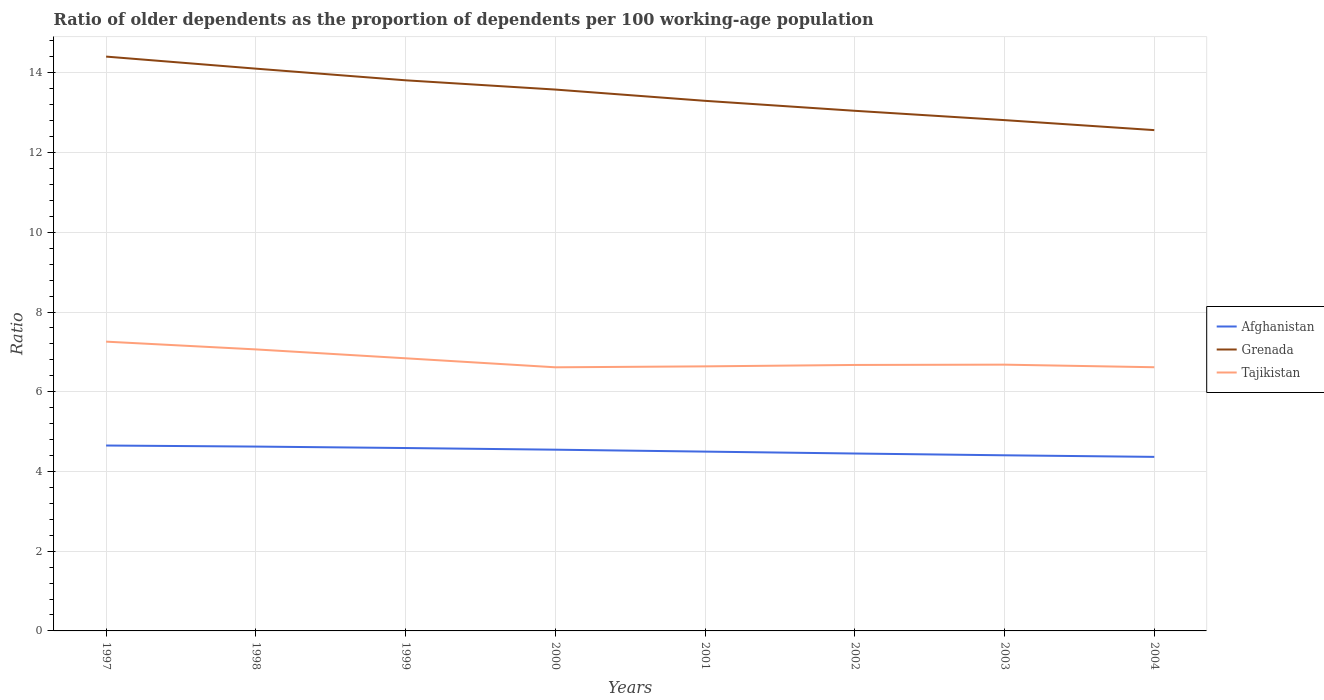How many different coloured lines are there?
Give a very brief answer. 3. Does the line corresponding to Afghanistan intersect with the line corresponding to Tajikistan?
Make the answer very short. No. Is the number of lines equal to the number of legend labels?
Give a very brief answer. Yes. Across all years, what is the maximum age dependency ratio(old) in Tajikistan?
Your response must be concise. 6.61. What is the total age dependency ratio(old) in Afghanistan in the graph?
Provide a short and direct response. 0.2. What is the difference between the highest and the second highest age dependency ratio(old) in Grenada?
Keep it short and to the point. 1.84. What is the difference between the highest and the lowest age dependency ratio(old) in Afghanistan?
Your answer should be compact. 4. How many years are there in the graph?
Keep it short and to the point. 8. Does the graph contain grids?
Your answer should be very brief. Yes. Where does the legend appear in the graph?
Keep it short and to the point. Center right. How are the legend labels stacked?
Give a very brief answer. Vertical. What is the title of the graph?
Your answer should be very brief. Ratio of older dependents as the proportion of dependents per 100 working-age population. What is the label or title of the X-axis?
Your response must be concise. Years. What is the label or title of the Y-axis?
Ensure brevity in your answer.  Ratio. What is the Ratio in Afghanistan in 1997?
Provide a succinct answer. 4.65. What is the Ratio of Grenada in 1997?
Your answer should be very brief. 14.41. What is the Ratio in Tajikistan in 1997?
Keep it short and to the point. 7.26. What is the Ratio of Afghanistan in 1998?
Ensure brevity in your answer.  4.62. What is the Ratio in Grenada in 1998?
Your response must be concise. 14.11. What is the Ratio of Tajikistan in 1998?
Provide a succinct answer. 7.06. What is the Ratio of Afghanistan in 1999?
Your answer should be compact. 4.59. What is the Ratio in Grenada in 1999?
Your response must be concise. 13.81. What is the Ratio of Tajikistan in 1999?
Provide a succinct answer. 6.84. What is the Ratio of Afghanistan in 2000?
Your answer should be compact. 4.55. What is the Ratio in Grenada in 2000?
Your answer should be compact. 13.58. What is the Ratio in Tajikistan in 2000?
Offer a terse response. 6.61. What is the Ratio in Afghanistan in 2001?
Your answer should be compact. 4.5. What is the Ratio of Grenada in 2001?
Provide a short and direct response. 13.3. What is the Ratio in Tajikistan in 2001?
Offer a terse response. 6.64. What is the Ratio of Afghanistan in 2002?
Provide a short and direct response. 4.45. What is the Ratio in Grenada in 2002?
Provide a short and direct response. 13.05. What is the Ratio of Tajikistan in 2002?
Your answer should be very brief. 6.67. What is the Ratio of Afghanistan in 2003?
Your answer should be very brief. 4.41. What is the Ratio of Grenada in 2003?
Your answer should be very brief. 12.81. What is the Ratio in Tajikistan in 2003?
Your answer should be very brief. 6.68. What is the Ratio in Afghanistan in 2004?
Your response must be concise. 4.37. What is the Ratio of Grenada in 2004?
Ensure brevity in your answer.  12.56. What is the Ratio of Tajikistan in 2004?
Keep it short and to the point. 6.61. Across all years, what is the maximum Ratio of Afghanistan?
Provide a short and direct response. 4.65. Across all years, what is the maximum Ratio of Grenada?
Provide a short and direct response. 14.41. Across all years, what is the maximum Ratio in Tajikistan?
Your answer should be very brief. 7.26. Across all years, what is the minimum Ratio in Afghanistan?
Provide a short and direct response. 4.37. Across all years, what is the minimum Ratio in Grenada?
Your response must be concise. 12.56. Across all years, what is the minimum Ratio in Tajikistan?
Make the answer very short. 6.61. What is the total Ratio of Afghanistan in the graph?
Your answer should be very brief. 36.13. What is the total Ratio of Grenada in the graph?
Give a very brief answer. 107.63. What is the total Ratio of Tajikistan in the graph?
Provide a succinct answer. 54.37. What is the difference between the Ratio in Afghanistan in 1997 and that in 1998?
Keep it short and to the point. 0.03. What is the difference between the Ratio in Grenada in 1997 and that in 1998?
Your response must be concise. 0.3. What is the difference between the Ratio of Tajikistan in 1997 and that in 1998?
Make the answer very short. 0.19. What is the difference between the Ratio of Afghanistan in 1997 and that in 1999?
Ensure brevity in your answer.  0.06. What is the difference between the Ratio of Grenada in 1997 and that in 1999?
Provide a short and direct response. 0.59. What is the difference between the Ratio of Tajikistan in 1997 and that in 1999?
Provide a short and direct response. 0.42. What is the difference between the Ratio of Afghanistan in 1997 and that in 2000?
Make the answer very short. 0.1. What is the difference between the Ratio of Grenada in 1997 and that in 2000?
Give a very brief answer. 0.83. What is the difference between the Ratio in Tajikistan in 1997 and that in 2000?
Give a very brief answer. 0.64. What is the difference between the Ratio of Afghanistan in 1997 and that in 2001?
Give a very brief answer. 0.15. What is the difference between the Ratio in Grenada in 1997 and that in 2001?
Give a very brief answer. 1.11. What is the difference between the Ratio in Tajikistan in 1997 and that in 2001?
Provide a succinct answer. 0.62. What is the difference between the Ratio in Afghanistan in 1997 and that in 2002?
Ensure brevity in your answer.  0.2. What is the difference between the Ratio in Grenada in 1997 and that in 2002?
Offer a terse response. 1.36. What is the difference between the Ratio in Tajikistan in 1997 and that in 2002?
Give a very brief answer. 0.58. What is the difference between the Ratio of Afghanistan in 1997 and that in 2003?
Offer a very short reply. 0.25. What is the difference between the Ratio of Grenada in 1997 and that in 2003?
Make the answer very short. 1.59. What is the difference between the Ratio in Tajikistan in 1997 and that in 2003?
Your response must be concise. 0.58. What is the difference between the Ratio in Afghanistan in 1997 and that in 2004?
Your response must be concise. 0.28. What is the difference between the Ratio in Grenada in 1997 and that in 2004?
Your answer should be compact. 1.84. What is the difference between the Ratio of Tajikistan in 1997 and that in 2004?
Provide a short and direct response. 0.64. What is the difference between the Ratio in Afghanistan in 1998 and that in 1999?
Ensure brevity in your answer.  0.04. What is the difference between the Ratio of Grenada in 1998 and that in 1999?
Offer a terse response. 0.29. What is the difference between the Ratio of Tajikistan in 1998 and that in 1999?
Keep it short and to the point. 0.22. What is the difference between the Ratio of Afghanistan in 1998 and that in 2000?
Keep it short and to the point. 0.08. What is the difference between the Ratio of Grenada in 1998 and that in 2000?
Make the answer very short. 0.52. What is the difference between the Ratio of Tajikistan in 1998 and that in 2000?
Ensure brevity in your answer.  0.45. What is the difference between the Ratio in Afghanistan in 1998 and that in 2001?
Give a very brief answer. 0.13. What is the difference between the Ratio in Grenada in 1998 and that in 2001?
Offer a terse response. 0.81. What is the difference between the Ratio in Tajikistan in 1998 and that in 2001?
Make the answer very short. 0.43. What is the difference between the Ratio of Afghanistan in 1998 and that in 2002?
Keep it short and to the point. 0.17. What is the difference between the Ratio of Grenada in 1998 and that in 2002?
Your answer should be very brief. 1.06. What is the difference between the Ratio in Tajikistan in 1998 and that in 2002?
Give a very brief answer. 0.39. What is the difference between the Ratio of Afghanistan in 1998 and that in 2003?
Provide a short and direct response. 0.22. What is the difference between the Ratio of Grenada in 1998 and that in 2003?
Your answer should be very brief. 1.29. What is the difference between the Ratio in Tajikistan in 1998 and that in 2003?
Offer a terse response. 0.38. What is the difference between the Ratio of Afghanistan in 1998 and that in 2004?
Offer a terse response. 0.26. What is the difference between the Ratio of Grenada in 1998 and that in 2004?
Keep it short and to the point. 1.54. What is the difference between the Ratio in Tajikistan in 1998 and that in 2004?
Your answer should be very brief. 0.45. What is the difference between the Ratio in Afghanistan in 1999 and that in 2000?
Make the answer very short. 0.04. What is the difference between the Ratio in Grenada in 1999 and that in 2000?
Provide a succinct answer. 0.23. What is the difference between the Ratio in Tajikistan in 1999 and that in 2000?
Provide a short and direct response. 0.23. What is the difference between the Ratio of Afghanistan in 1999 and that in 2001?
Ensure brevity in your answer.  0.09. What is the difference between the Ratio of Grenada in 1999 and that in 2001?
Your response must be concise. 0.51. What is the difference between the Ratio in Tajikistan in 1999 and that in 2001?
Your answer should be very brief. 0.2. What is the difference between the Ratio of Afghanistan in 1999 and that in 2002?
Provide a succinct answer. 0.14. What is the difference between the Ratio of Grenada in 1999 and that in 2002?
Make the answer very short. 0.76. What is the difference between the Ratio in Tajikistan in 1999 and that in 2002?
Offer a terse response. 0.17. What is the difference between the Ratio of Afghanistan in 1999 and that in 2003?
Offer a very short reply. 0.18. What is the difference between the Ratio of Tajikistan in 1999 and that in 2003?
Offer a very short reply. 0.16. What is the difference between the Ratio in Afghanistan in 1999 and that in 2004?
Ensure brevity in your answer.  0.22. What is the difference between the Ratio of Grenada in 1999 and that in 2004?
Provide a short and direct response. 1.25. What is the difference between the Ratio in Tajikistan in 1999 and that in 2004?
Provide a succinct answer. 0.22. What is the difference between the Ratio of Afghanistan in 2000 and that in 2001?
Provide a short and direct response. 0.05. What is the difference between the Ratio of Grenada in 2000 and that in 2001?
Your answer should be very brief. 0.28. What is the difference between the Ratio in Tajikistan in 2000 and that in 2001?
Keep it short and to the point. -0.02. What is the difference between the Ratio of Afghanistan in 2000 and that in 2002?
Provide a short and direct response. 0.1. What is the difference between the Ratio in Grenada in 2000 and that in 2002?
Provide a succinct answer. 0.53. What is the difference between the Ratio of Tajikistan in 2000 and that in 2002?
Make the answer very short. -0.06. What is the difference between the Ratio in Afghanistan in 2000 and that in 2003?
Provide a succinct answer. 0.14. What is the difference between the Ratio in Grenada in 2000 and that in 2003?
Keep it short and to the point. 0.77. What is the difference between the Ratio of Tajikistan in 2000 and that in 2003?
Your answer should be very brief. -0.07. What is the difference between the Ratio in Afghanistan in 2000 and that in 2004?
Your answer should be very brief. 0.18. What is the difference between the Ratio in Grenada in 2000 and that in 2004?
Provide a succinct answer. 1.02. What is the difference between the Ratio of Tajikistan in 2000 and that in 2004?
Ensure brevity in your answer.  -0. What is the difference between the Ratio of Afghanistan in 2001 and that in 2002?
Provide a succinct answer. 0.05. What is the difference between the Ratio of Grenada in 2001 and that in 2002?
Your response must be concise. 0.25. What is the difference between the Ratio of Tajikistan in 2001 and that in 2002?
Your response must be concise. -0.04. What is the difference between the Ratio in Afghanistan in 2001 and that in 2003?
Offer a terse response. 0.09. What is the difference between the Ratio in Grenada in 2001 and that in 2003?
Offer a very short reply. 0.48. What is the difference between the Ratio of Tajikistan in 2001 and that in 2003?
Offer a terse response. -0.04. What is the difference between the Ratio in Afghanistan in 2001 and that in 2004?
Your answer should be compact. 0.13. What is the difference between the Ratio in Grenada in 2001 and that in 2004?
Ensure brevity in your answer.  0.73. What is the difference between the Ratio in Tajikistan in 2001 and that in 2004?
Keep it short and to the point. 0.02. What is the difference between the Ratio in Afghanistan in 2002 and that in 2003?
Your answer should be compact. 0.04. What is the difference between the Ratio of Grenada in 2002 and that in 2003?
Your response must be concise. 0.23. What is the difference between the Ratio in Tajikistan in 2002 and that in 2003?
Provide a short and direct response. -0.01. What is the difference between the Ratio of Afghanistan in 2002 and that in 2004?
Your answer should be very brief. 0.08. What is the difference between the Ratio of Grenada in 2002 and that in 2004?
Provide a succinct answer. 0.48. What is the difference between the Ratio in Tajikistan in 2002 and that in 2004?
Give a very brief answer. 0.06. What is the difference between the Ratio in Afghanistan in 2003 and that in 2004?
Offer a very short reply. 0.04. What is the difference between the Ratio in Grenada in 2003 and that in 2004?
Ensure brevity in your answer.  0.25. What is the difference between the Ratio of Tajikistan in 2003 and that in 2004?
Provide a short and direct response. 0.06. What is the difference between the Ratio of Afghanistan in 1997 and the Ratio of Grenada in 1998?
Your response must be concise. -9.45. What is the difference between the Ratio of Afghanistan in 1997 and the Ratio of Tajikistan in 1998?
Your answer should be compact. -2.41. What is the difference between the Ratio in Grenada in 1997 and the Ratio in Tajikistan in 1998?
Give a very brief answer. 7.35. What is the difference between the Ratio of Afghanistan in 1997 and the Ratio of Grenada in 1999?
Give a very brief answer. -9.16. What is the difference between the Ratio of Afghanistan in 1997 and the Ratio of Tajikistan in 1999?
Ensure brevity in your answer.  -2.19. What is the difference between the Ratio in Grenada in 1997 and the Ratio in Tajikistan in 1999?
Offer a terse response. 7.57. What is the difference between the Ratio in Afghanistan in 1997 and the Ratio in Grenada in 2000?
Your answer should be compact. -8.93. What is the difference between the Ratio in Afghanistan in 1997 and the Ratio in Tajikistan in 2000?
Ensure brevity in your answer.  -1.96. What is the difference between the Ratio of Grenada in 1997 and the Ratio of Tajikistan in 2000?
Offer a very short reply. 7.79. What is the difference between the Ratio in Afghanistan in 1997 and the Ratio in Grenada in 2001?
Offer a terse response. -8.65. What is the difference between the Ratio of Afghanistan in 1997 and the Ratio of Tajikistan in 2001?
Give a very brief answer. -1.99. What is the difference between the Ratio of Grenada in 1997 and the Ratio of Tajikistan in 2001?
Your answer should be very brief. 7.77. What is the difference between the Ratio in Afghanistan in 1997 and the Ratio in Grenada in 2002?
Make the answer very short. -8.4. What is the difference between the Ratio in Afghanistan in 1997 and the Ratio in Tajikistan in 2002?
Provide a short and direct response. -2.02. What is the difference between the Ratio of Grenada in 1997 and the Ratio of Tajikistan in 2002?
Give a very brief answer. 7.74. What is the difference between the Ratio of Afghanistan in 1997 and the Ratio of Grenada in 2003?
Your answer should be very brief. -8.16. What is the difference between the Ratio in Afghanistan in 1997 and the Ratio in Tajikistan in 2003?
Your answer should be very brief. -2.03. What is the difference between the Ratio in Grenada in 1997 and the Ratio in Tajikistan in 2003?
Offer a very short reply. 7.73. What is the difference between the Ratio of Afghanistan in 1997 and the Ratio of Grenada in 2004?
Your response must be concise. -7.91. What is the difference between the Ratio in Afghanistan in 1997 and the Ratio in Tajikistan in 2004?
Provide a succinct answer. -1.96. What is the difference between the Ratio of Grenada in 1997 and the Ratio of Tajikistan in 2004?
Offer a terse response. 7.79. What is the difference between the Ratio in Afghanistan in 1998 and the Ratio in Grenada in 1999?
Provide a short and direct response. -9.19. What is the difference between the Ratio of Afghanistan in 1998 and the Ratio of Tajikistan in 1999?
Provide a succinct answer. -2.21. What is the difference between the Ratio in Grenada in 1998 and the Ratio in Tajikistan in 1999?
Ensure brevity in your answer.  7.27. What is the difference between the Ratio in Afghanistan in 1998 and the Ratio in Grenada in 2000?
Provide a succinct answer. -8.96. What is the difference between the Ratio of Afghanistan in 1998 and the Ratio of Tajikistan in 2000?
Give a very brief answer. -1.99. What is the difference between the Ratio of Grenada in 1998 and the Ratio of Tajikistan in 2000?
Provide a succinct answer. 7.49. What is the difference between the Ratio of Afghanistan in 1998 and the Ratio of Grenada in 2001?
Offer a very short reply. -8.67. What is the difference between the Ratio of Afghanistan in 1998 and the Ratio of Tajikistan in 2001?
Offer a very short reply. -2.01. What is the difference between the Ratio in Grenada in 1998 and the Ratio in Tajikistan in 2001?
Your answer should be compact. 7.47. What is the difference between the Ratio of Afghanistan in 1998 and the Ratio of Grenada in 2002?
Your response must be concise. -8.42. What is the difference between the Ratio in Afghanistan in 1998 and the Ratio in Tajikistan in 2002?
Your answer should be compact. -2.05. What is the difference between the Ratio of Grenada in 1998 and the Ratio of Tajikistan in 2002?
Your answer should be compact. 7.43. What is the difference between the Ratio in Afghanistan in 1998 and the Ratio in Grenada in 2003?
Your answer should be compact. -8.19. What is the difference between the Ratio in Afghanistan in 1998 and the Ratio in Tajikistan in 2003?
Give a very brief answer. -2.06. What is the difference between the Ratio of Grenada in 1998 and the Ratio of Tajikistan in 2003?
Make the answer very short. 7.43. What is the difference between the Ratio of Afghanistan in 1998 and the Ratio of Grenada in 2004?
Your answer should be compact. -7.94. What is the difference between the Ratio in Afghanistan in 1998 and the Ratio in Tajikistan in 2004?
Give a very brief answer. -1.99. What is the difference between the Ratio of Grenada in 1998 and the Ratio of Tajikistan in 2004?
Offer a terse response. 7.49. What is the difference between the Ratio of Afghanistan in 1999 and the Ratio of Grenada in 2000?
Your response must be concise. -8.99. What is the difference between the Ratio in Afghanistan in 1999 and the Ratio in Tajikistan in 2000?
Your answer should be very brief. -2.03. What is the difference between the Ratio of Grenada in 1999 and the Ratio of Tajikistan in 2000?
Provide a short and direct response. 7.2. What is the difference between the Ratio in Afghanistan in 1999 and the Ratio in Grenada in 2001?
Keep it short and to the point. -8.71. What is the difference between the Ratio in Afghanistan in 1999 and the Ratio in Tajikistan in 2001?
Keep it short and to the point. -2.05. What is the difference between the Ratio of Grenada in 1999 and the Ratio of Tajikistan in 2001?
Your answer should be very brief. 7.18. What is the difference between the Ratio of Afghanistan in 1999 and the Ratio of Grenada in 2002?
Provide a short and direct response. -8.46. What is the difference between the Ratio of Afghanistan in 1999 and the Ratio of Tajikistan in 2002?
Provide a short and direct response. -2.08. What is the difference between the Ratio in Grenada in 1999 and the Ratio in Tajikistan in 2002?
Your response must be concise. 7.14. What is the difference between the Ratio of Afghanistan in 1999 and the Ratio of Grenada in 2003?
Ensure brevity in your answer.  -8.23. What is the difference between the Ratio of Afghanistan in 1999 and the Ratio of Tajikistan in 2003?
Offer a very short reply. -2.09. What is the difference between the Ratio in Grenada in 1999 and the Ratio in Tajikistan in 2003?
Offer a terse response. 7.13. What is the difference between the Ratio in Afghanistan in 1999 and the Ratio in Grenada in 2004?
Keep it short and to the point. -7.97. What is the difference between the Ratio in Afghanistan in 1999 and the Ratio in Tajikistan in 2004?
Offer a very short reply. -2.03. What is the difference between the Ratio in Grenada in 1999 and the Ratio in Tajikistan in 2004?
Keep it short and to the point. 7.2. What is the difference between the Ratio in Afghanistan in 2000 and the Ratio in Grenada in 2001?
Offer a very short reply. -8.75. What is the difference between the Ratio of Afghanistan in 2000 and the Ratio of Tajikistan in 2001?
Offer a very short reply. -2.09. What is the difference between the Ratio of Grenada in 2000 and the Ratio of Tajikistan in 2001?
Provide a short and direct response. 6.94. What is the difference between the Ratio of Afghanistan in 2000 and the Ratio of Grenada in 2002?
Offer a terse response. -8.5. What is the difference between the Ratio of Afghanistan in 2000 and the Ratio of Tajikistan in 2002?
Offer a terse response. -2.13. What is the difference between the Ratio of Grenada in 2000 and the Ratio of Tajikistan in 2002?
Provide a short and direct response. 6.91. What is the difference between the Ratio of Afghanistan in 2000 and the Ratio of Grenada in 2003?
Your response must be concise. -8.27. What is the difference between the Ratio of Afghanistan in 2000 and the Ratio of Tajikistan in 2003?
Provide a short and direct response. -2.13. What is the difference between the Ratio in Grenada in 2000 and the Ratio in Tajikistan in 2003?
Give a very brief answer. 6.9. What is the difference between the Ratio in Afghanistan in 2000 and the Ratio in Grenada in 2004?
Provide a succinct answer. -8.02. What is the difference between the Ratio in Afghanistan in 2000 and the Ratio in Tajikistan in 2004?
Provide a succinct answer. -2.07. What is the difference between the Ratio in Grenada in 2000 and the Ratio in Tajikistan in 2004?
Keep it short and to the point. 6.97. What is the difference between the Ratio in Afghanistan in 2001 and the Ratio in Grenada in 2002?
Your answer should be very brief. -8.55. What is the difference between the Ratio in Afghanistan in 2001 and the Ratio in Tajikistan in 2002?
Give a very brief answer. -2.17. What is the difference between the Ratio in Grenada in 2001 and the Ratio in Tajikistan in 2002?
Offer a very short reply. 6.63. What is the difference between the Ratio in Afghanistan in 2001 and the Ratio in Grenada in 2003?
Offer a very short reply. -8.32. What is the difference between the Ratio of Afghanistan in 2001 and the Ratio of Tajikistan in 2003?
Give a very brief answer. -2.18. What is the difference between the Ratio in Grenada in 2001 and the Ratio in Tajikistan in 2003?
Your answer should be compact. 6.62. What is the difference between the Ratio in Afghanistan in 2001 and the Ratio in Grenada in 2004?
Offer a very short reply. -8.06. What is the difference between the Ratio of Afghanistan in 2001 and the Ratio of Tajikistan in 2004?
Your answer should be compact. -2.12. What is the difference between the Ratio of Grenada in 2001 and the Ratio of Tajikistan in 2004?
Give a very brief answer. 6.68. What is the difference between the Ratio of Afghanistan in 2002 and the Ratio of Grenada in 2003?
Your answer should be compact. -8.36. What is the difference between the Ratio of Afghanistan in 2002 and the Ratio of Tajikistan in 2003?
Your response must be concise. -2.23. What is the difference between the Ratio in Grenada in 2002 and the Ratio in Tajikistan in 2003?
Your answer should be compact. 6.37. What is the difference between the Ratio of Afghanistan in 2002 and the Ratio of Grenada in 2004?
Your response must be concise. -8.11. What is the difference between the Ratio of Afghanistan in 2002 and the Ratio of Tajikistan in 2004?
Ensure brevity in your answer.  -2.16. What is the difference between the Ratio of Grenada in 2002 and the Ratio of Tajikistan in 2004?
Your answer should be very brief. 6.43. What is the difference between the Ratio in Afghanistan in 2003 and the Ratio in Grenada in 2004?
Keep it short and to the point. -8.16. What is the difference between the Ratio of Afghanistan in 2003 and the Ratio of Tajikistan in 2004?
Your response must be concise. -2.21. What is the difference between the Ratio of Grenada in 2003 and the Ratio of Tajikistan in 2004?
Your response must be concise. 6.2. What is the average Ratio in Afghanistan per year?
Offer a terse response. 4.52. What is the average Ratio in Grenada per year?
Your response must be concise. 13.45. What is the average Ratio in Tajikistan per year?
Keep it short and to the point. 6.8. In the year 1997, what is the difference between the Ratio in Afghanistan and Ratio in Grenada?
Your response must be concise. -9.76. In the year 1997, what is the difference between the Ratio of Afghanistan and Ratio of Tajikistan?
Offer a very short reply. -2.61. In the year 1997, what is the difference between the Ratio in Grenada and Ratio in Tajikistan?
Ensure brevity in your answer.  7.15. In the year 1998, what is the difference between the Ratio in Afghanistan and Ratio in Grenada?
Provide a short and direct response. -9.48. In the year 1998, what is the difference between the Ratio in Afghanistan and Ratio in Tajikistan?
Give a very brief answer. -2.44. In the year 1998, what is the difference between the Ratio of Grenada and Ratio of Tajikistan?
Offer a very short reply. 7.04. In the year 1999, what is the difference between the Ratio in Afghanistan and Ratio in Grenada?
Ensure brevity in your answer.  -9.22. In the year 1999, what is the difference between the Ratio of Afghanistan and Ratio of Tajikistan?
Provide a short and direct response. -2.25. In the year 1999, what is the difference between the Ratio in Grenada and Ratio in Tajikistan?
Your response must be concise. 6.97. In the year 2000, what is the difference between the Ratio in Afghanistan and Ratio in Grenada?
Your response must be concise. -9.03. In the year 2000, what is the difference between the Ratio in Afghanistan and Ratio in Tajikistan?
Provide a short and direct response. -2.07. In the year 2000, what is the difference between the Ratio in Grenada and Ratio in Tajikistan?
Ensure brevity in your answer.  6.97. In the year 2001, what is the difference between the Ratio in Afghanistan and Ratio in Grenada?
Your answer should be compact. -8.8. In the year 2001, what is the difference between the Ratio in Afghanistan and Ratio in Tajikistan?
Offer a very short reply. -2.14. In the year 2001, what is the difference between the Ratio of Grenada and Ratio of Tajikistan?
Your response must be concise. 6.66. In the year 2002, what is the difference between the Ratio of Afghanistan and Ratio of Grenada?
Your response must be concise. -8.6. In the year 2002, what is the difference between the Ratio in Afghanistan and Ratio in Tajikistan?
Your answer should be compact. -2.22. In the year 2002, what is the difference between the Ratio of Grenada and Ratio of Tajikistan?
Your response must be concise. 6.38. In the year 2003, what is the difference between the Ratio in Afghanistan and Ratio in Grenada?
Keep it short and to the point. -8.41. In the year 2003, what is the difference between the Ratio of Afghanistan and Ratio of Tajikistan?
Ensure brevity in your answer.  -2.27. In the year 2003, what is the difference between the Ratio in Grenada and Ratio in Tajikistan?
Ensure brevity in your answer.  6.13. In the year 2004, what is the difference between the Ratio of Afghanistan and Ratio of Grenada?
Ensure brevity in your answer.  -8.2. In the year 2004, what is the difference between the Ratio of Afghanistan and Ratio of Tajikistan?
Give a very brief answer. -2.25. In the year 2004, what is the difference between the Ratio of Grenada and Ratio of Tajikistan?
Keep it short and to the point. 5.95. What is the ratio of the Ratio of Afghanistan in 1997 to that in 1998?
Provide a succinct answer. 1.01. What is the ratio of the Ratio in Grenada in 1997 to that in 1998?
Your answer should be compact. 1.02. What is the ratio of the Ratio in Tajikistan in 1997 to that in 1998?
Your answer should be compact. 1.03. What is the ratio of the Ratio of Afghanistan in 1997 to that in 1999?
Make the answer very short. 1.01. What is the ratio of the Ratio in Grenada in 1997 to that in 1999?
Your response must be concise. 1.04. What is the ratio of the Ratio in Tajikistan in 1997 to that in 1999?
Your answer should be very brief. 1.06. What is the ratio of the Ratio in Afghanistan in 1997 to that in 2000?
Give a very brief answer. 1.02. What is the ratio of the Ratio of Grenada in 1997 to that in 2000?
Offer a very short reply. 1.06. What is the ratio of the Ratio of Tajikistan in 1997 to that in 2000?
Ensure brevity in your answer.  1.1. What is the ratio of the Ratio in Afghanistan in 1997 to that in 2001?
Make the answer very short. 1.03. What is the ratio of the Ratio of Grenada in 1997 to that in 2001?
Give a very brief answer. 1.08. What is the ratio of the Ratio in Tajikistan in 1997 to that in 2001?
Offer a very short reply. 1.09. What is the ratio of the Ratio of Afghanistan in 1997 to that in 2002?
Provide a succinct answer. 1.05. What is the ratio of the Ratio of Grenada in 1997 to that in 2002?
Your response must be concise. 1.1. What is the ratio of the Ratio of Tajikistan in 1997 to that in 2002?
Your response must be concise. 1.09. What is the ratio of the Ratio of Afghanistan in 1997 to that in 2003?
Provide a succinct answer. 1.06. What is the ratio of the Ratio in Grenada in 1997 to that in 2003?
Provide a short and direct response. 1.12. What is the ratio of the Ratio in Tajikistan in 1997 to that in 2003?
Make the answer very short. 1.09. What is the ratio of the Ratio of Afghanistan in 1997 to that in 2004?
Keep it short and to the point. 1.07. What is the ratio of the Ratio of Grenada in 1997 to that in 2004?
Provide a succinct answer. 1.15. What is the ratio of the Ratio in Tajikistan in 1997 to that in 2004?
Offer a very short reply. 1.1. What is the ratio of the Ratio in Afghanistan in 1998 to that in 1999?
Ensure brevity in your answer.  1.01. What is the ratio of the Ratio of Grenada in 1998 to that in 1999?
Make the answer very short. 1.02. What is the ratio of the Ratio of Tajikistan in 1998 to that in 1999?
Your answer should be very brief. 1.03. What is the ratio of the Ratio of Afghanistan in 1998 to that in 2000?
Your answer should be very brief. 1.02. What is the ratio of the Ratio in Grenada in 1998 to that in 2000?
Offer a terse response. 1.04. What is the ratio of the Ratio in Tajikistan in 1998 to that in 2000?
Your answer should be compact. 1.07. What is the ratio of the Ratio in Afghanistan in 1998 to that in 2001?
Make the answer very short. 1.03. What is the ratio of the Ratio of Grenada in 1998 to that in 2001?
Ensure brevity in your answer.  1.06. What is the ratio of the Ratio of Tajikistan in 1998 to that in 2001?
Your answer should be compact. 1.06. What is the ratio of the Ratio of Afghanistan in 1998 to that in 2002?
Give a very brief answer. 1.04. What is the ratio of the Ratio in Grenada in 1998 to that in 2002?
Offer a terse response. 1.08. What is the ratio of the Ratio of Tajikistan in 1998 to that in 2002?
Your answer should be compact. 1.06. What is the ratio of the Ratio of Afghanistan in 1998 to that in 2003?
Offer a terse response. 1.05. What is the ratio of the Ratio in Grenada in 1998 to that in 2003?
Your answer should be compact. 1.1. What is the ratio of the Ratio of Tajikistan in 1998 to that in 2003?
Provide a short and direct response. 1.06. What is the ratio of the Ratio in Afghanistan in 1998 to that in 2004?
Offer a very short reply. 1.06. What is the ratio of the Ratio in Grenada in 1998 to that in 2004?
Your answer should be very brief. 1.12. What is the ratio of the Ratio in Tajikistan in 1998 to that in 2004?
Provide a succinct answer. 1.07. What is the ratio of the Ratio of Afghanistan in 1999 to that in 2000?
Give a very brief answer. 1.01. What is the ratio of the Ratio in Grenada in 1999 to that in 2000?
Offer a terse response. 1.02. What is the ratio of the Ratio in Tajikistan in 1999 to that in 2000?
Provide a succinct answer. 1.03. What is the ratio of the Ratio of Grenada in 1999 to that in 2001?
Ensure brevity in your answer.  1.04. What is the ratio of the Ratio in Tajikistan in 1999 to that in 2001?
Offer a very short reply. 1.03. What is the ratio of the Ratio of Afghanistan in 1999 to that in 2002?
Make the answer very short. 1.03. What is the ratio of the Ratio of Grenada in 1999 to that in 2002?
Offer a very short reply. 1.06. What is the ratio of the Ratio of Tajikistan in 1999 to that in 2002?
Provide a short and direct response. 1.03. What is the ratio of the Ratio in Afghanistan in 1999 to that in 2003?
Your answer should be compact. 1.04. What is the ratio of the Ratio in Grenada in 1999 to that in 2003?
Provide a succinct answer. 1.08. What is the ratio of the Ratio in Tajikistan in 1999 to that in 2003?
Provide a succinct answer. 1.02. What is the ratio of the Ratio in Afghanistan in 1999 to that in 2004?
Your answer should be very brief. 1.05. What is the ratio of the Ratio in Grenada in 1999 to that in 2004?
Keep it short and to the point. 1.1. What is the ratio of the Ratio in Tajikistan in 1999 to that in 2004?
Ensure brevity in your answer.  1.03. What is the ratio of the Ratio in Afghanistan in 2000 to that in 2001?
Give a very brief answer. 1.01. What is the ratio of the Ratio in Grenada in 2000 to that in 2001?
Keep it short and to the point. 1.02. What is the ratio of the Ratio of Tajikistan in 2000 to that in 2001?
Keep it short and to the point. 1. What is the ratio of the Ratio in Afghanistan in 2000 to that in 2002?
Provide a succinct answer. 1.02. What is the ratio of the Ratio of Grenada in 2000 to that in 2002?
Your answer should be compact. 1.04. What is the ratio of the Ratio of Tajikistan in 2000 to that in 2002?
Offer a very short reply. 0.99. What is the ratio of the Ratio of Afghanistan in 2000 to that in 2003?
Your answer should be very brief. 1.03. What is the ratio of the Ratio in Grenada in 2000 to that in 2003?
Keep it short and to the point. 1.06. What is the ratio of the Ratio of Tajikistan in 2000 to that in 2003?
Provide a succinct answer. 0.99. What is the ratio of the Ratio in Afghanistan in 2000 to that in 2004?
Ensure brevity in your answer.  1.04. What is the ratio of the Ratio of Grenada in 2000 to that in 2004?
Your answer should be very brief. 1.08. What is the ratio of the Ratio in Afghanistan in 2001 to that in 2002?
Make the answer very short. 1.01. What is the ratio of the Ratio of Grenada in 2001 to that in 2002?
Provide a short and direct response. 1.02. What is the ratio of the Ratio of Tajikistan in 2001 to that in 2002?
Keep it short and to the point. 0.99. What is the ratio of the Ratio of Grenada in 2001 to that in 2003?
Give a very brief answer. 1.04. What is the ratio of the Ratio of Afghanistan in 2001 to that in 2004?
Provide a short and direct response. 1.03. What is the ratio of the Ratio in Grenada in 2001 to that in 2004?
Your answer should be very brief. 1.06. What is the ratio of the Ratio of Afghanistan in 2002 to that in 2003?
Keep it short and to the point. 1.01. What is the ratio of the Ratio in Grenada in 2002 to that in 2003?
Your response must be concise. 1.02. What is the ratio of the Ratio of Tajikistan in 2002 to that in 2003?
Your answer should be very brief. 1. What is the ratio of the Ratio of Afghanistan in 2002 to that in 2004?
Provide a succinct answer. 1.02. What is the ratio of the Ratio of Grenada in 2002 to that in 2004?
Offer a terse response. 1.04. What is the ratio of the Ratio of Tajikistan in 2002 to that in 2004?
Offer a terse response. 1.01. What is the ratio of the Ratio of Afghanistan in 2003 to that in 2004?
Provide a succinct answer. 1.01. What is the ratio of the Ratio of Grenada in 2003 to that in 2004?
Give a very brief answer. 1.02. What is the ratio of the Ratio in Tajikistan in 2003 to that in 2004?
Make the answer very short. 1.01. What is the difference between the highest and the second highest Ratio in Afghanistan?
Keep it short and to the point. 0.03. What is the difference between the highest and the second highest Ratio in Grenada?
Keep it short and to the point. 0.3. What is the difference between the highest and the second highest Ratio of Tajikistan?
Your response must be concise. 0.19. What is the difference between the highest and the lowest Ratio of Afghanistan?
Your answer should be very brief. 0.28. What is the difference between the highest and the lowest Ratio of Grenada?
Offer a terse response. 1.84. What is the difference between the highest and the lowest Ratio in Tajikistan?
Your answer should be compact. 0.64. 